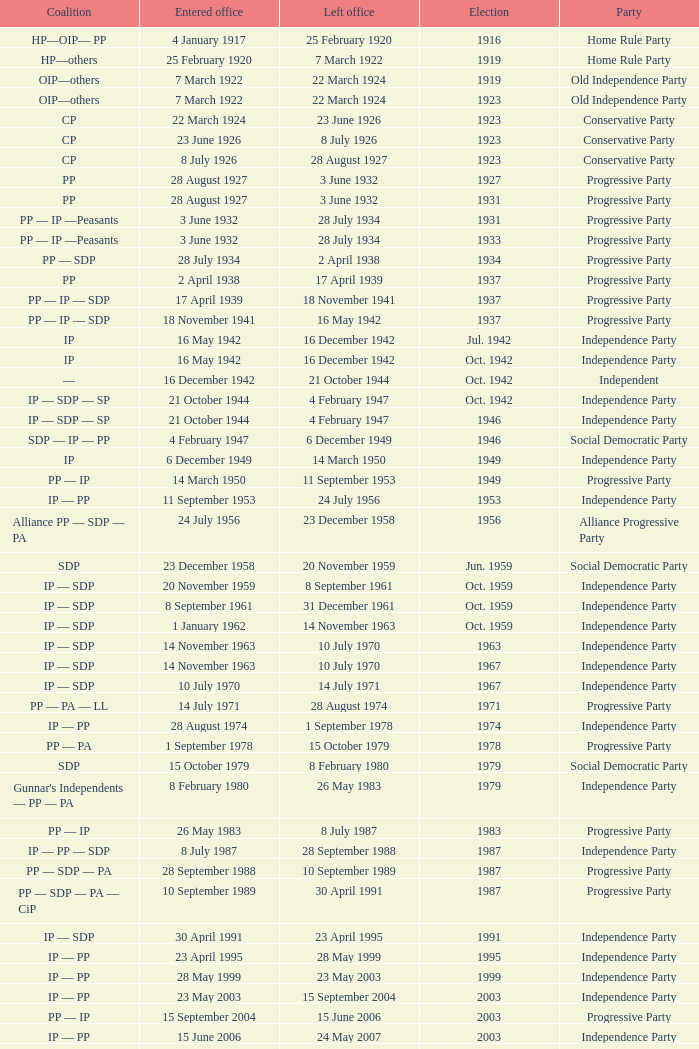When did the party elected in jun. 1959 enter office? 23 December 1958. 